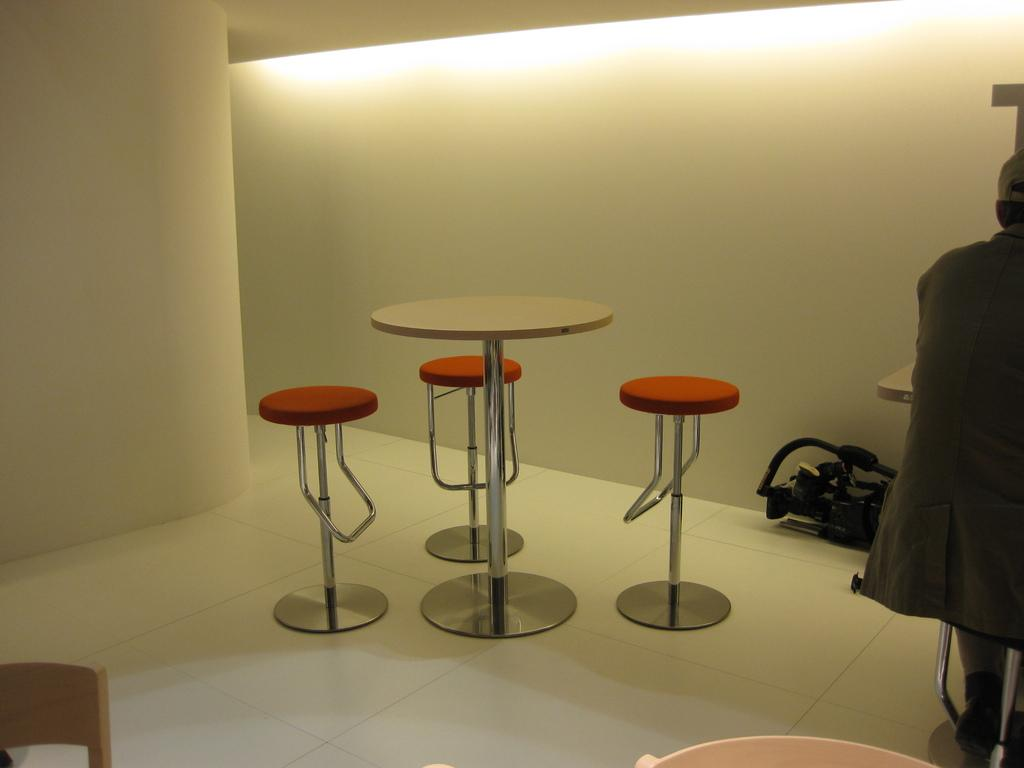How many stools are around the table in the image? There are three stools around the table in the image. What is the person in the image doing? The person is sitting on one of the stools. What type of apparel is the pig wearing in the image? There is no pig present in the image, so it is not possible to determine what type of apparel it might be wearing. 